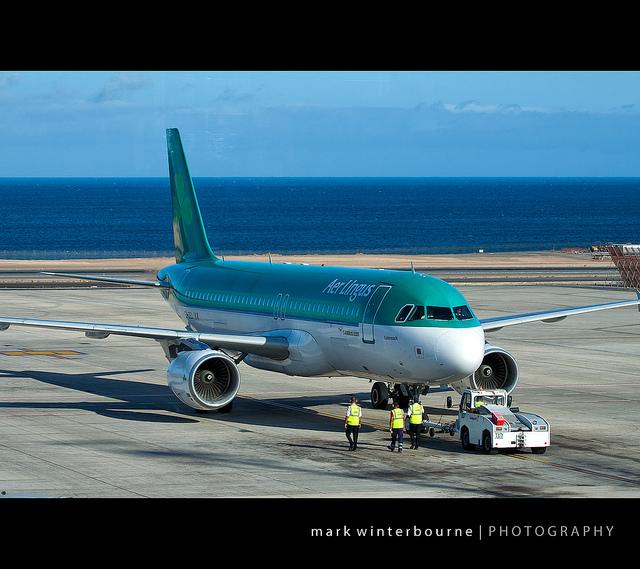Where is this?
Quick response, please. Airport. How many people are wearing yellow?
Quick response, please. 3. What airline is this?
Quick response, please. Aer lingus. How many planes?
Concise answer only. 1. 